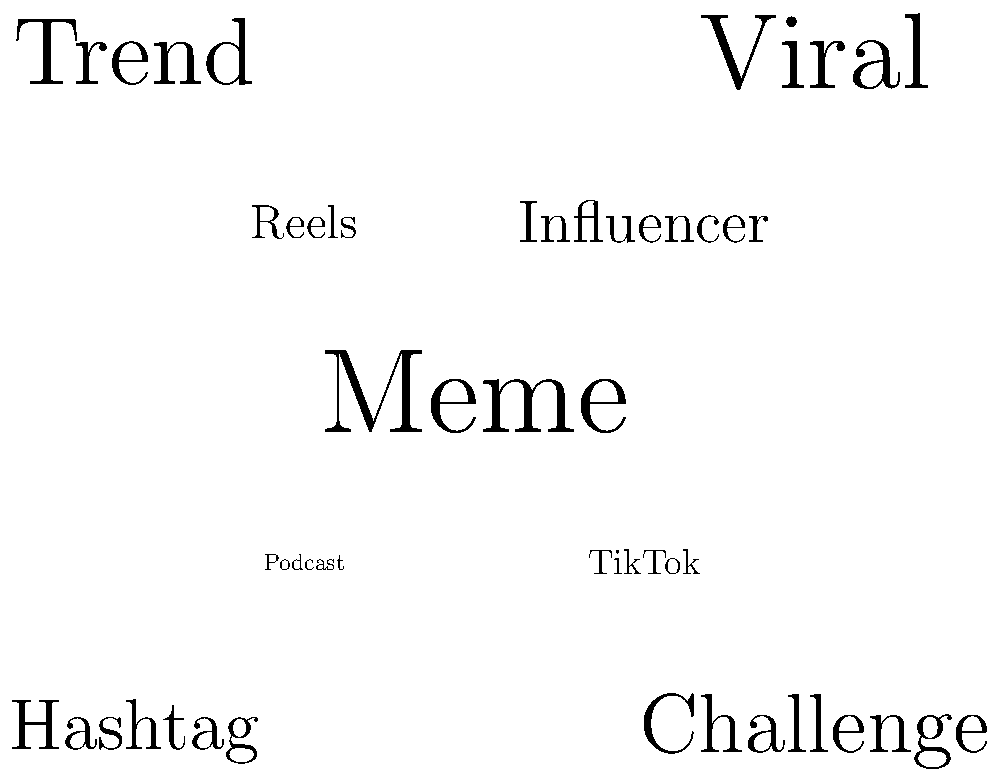As a comedian looking to stay current, which trending topic in this word cloud visualization would be most beneficial for crafting jokes about the evolving landscape of social media content creation? To answer this question, we need to analyze the word cloud visualization and consider the perspective of a comedian looking to create relevant jokes about social media trends. Let's break it down step-by-step:

1. Observe the word cloud: The largest words are typically the most prominent trends.
2. Identify the largest word: "Meme" appears to be the largest, indicating its significance in current social media trends.
3. Consider the comedic potential: Memes are often humorous and easily relatable, making them excellent material for jokes.
4. Evaluate other trends: While "Viral," "Trend," and "Challenge" are also prominent, they are more general concepts and may not offer as much specific comedic material as memes.
5. Think about the audience: Memes are widely understood and appreciated across different age groups and social media platforms.
6. Reflect on the evolving landscape: Memes represent how content is rapidly created, shared, and transformed on social media, embodying the fast-paced nature of online trends.
7. Consider the comedian's perspective: As an underrated comedian, focusing on memes could help in crafting jokes that resonate with a broad audience and potentially increase visibility.

Given these factors, "Meme" would be the most beneficial trending topic for a comedian to focus on when crafting jokes about the evolving landscape of social media content creation.
Answer: Meme 